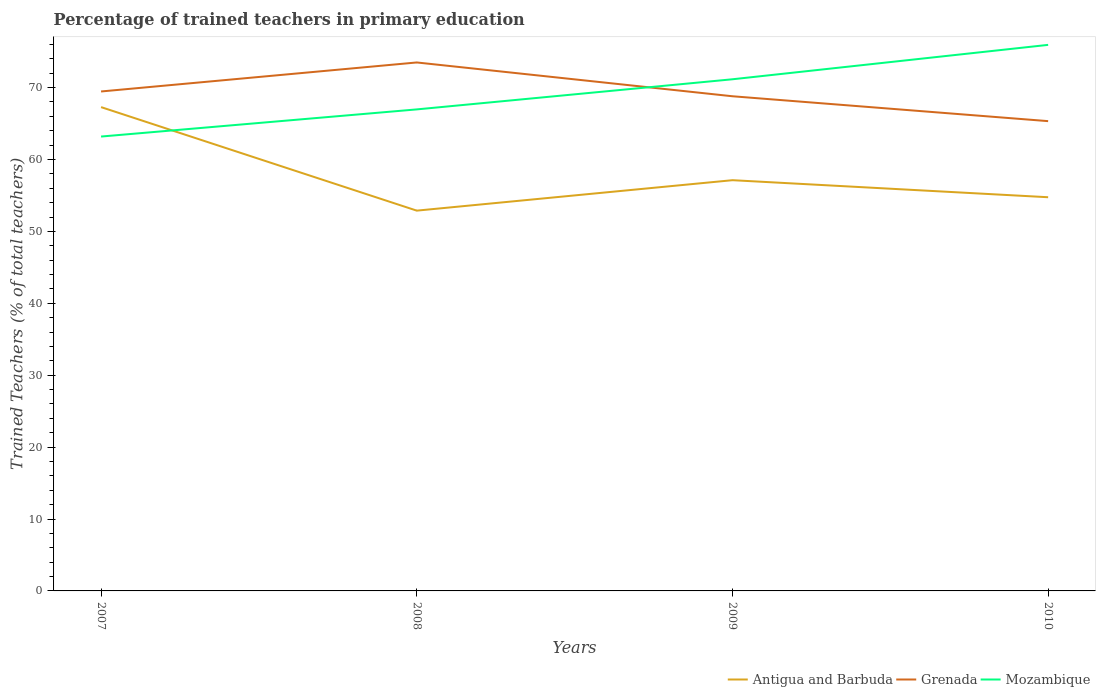How many different coloured lines are there?
Provide a succinct answer. 3. Does the line corresponding to Grenada intersect with the line corresponding to Mozambique?
Ensure brevity in your answer.  Yes. Is the number of lines equal to the number of legend labels?
Your answer should be very brief. Yes. Across all years, what is the maximum percentage of trained teachers in Mozambique?
Keep it short and to the point. 63.19. What is the total percentage of trained teachers in Mozambique in the graph?
Give a very brief answer. -7.97. What is the difference between the highest and the second highest percentage of trained teachers in Grenada?
Your answer should be compact. 8.16. What is the difference between the highest and the lowest percentage of trained teachers in Antigua and Barbuda?
Give a very brief answer. 1. How many lines are there?
Provide a succinct answer. 3. What is the difference between two consecutive major ticks on the Y-axis?
Your answer should be compact. 10. Does the graph contain grids?
Your answer should be compact. No. How many legend labels are there?
Provide a succinct answer. 3. What is the title of the graph?
Offer a terse response. Percentage of trained teachers in primary education. What is the label or title of the Y-axis?
Ensure brevity in your answer.  Trained Teachers (% of total teachers). What is the Trained Teachers (% of total teachers) of Antigua and Barbuda in 2007?
Your response must be concise. 67.29. What is the Trained Teachers (% of total teachers) of Grenada in 2007?
Keep it short and to the point. 69.46. What is the Trained Teachers (% of total teachers) in Mozambique in 2007?
Provide a succinct answer. 63.19. What is the Trained Teachers (% of total teachers) of Antigua and Barbuda in 2008?
Offer a very short reply. 52.89. What is the Trained Teachers (% of total teachers) of Grenada in 2008?
Offer a terse response. 73.5. What is the Trained Teachers (% of total teachers) of Mozambique in 2008?
Make the answer very short. 66.97. What is the Trained Teachers (% of total teachers) of Antigua and Barbuda in 2009?
Make the answer very short. 57.12. What is the Trained Teachers (% of total teachers) in Grenada in 2009?
Offer a terse response. 68.8. What is the Trained Teachers (% of total teachers) of Mozambique in 2009?
Your answer should be very brief. 71.16. What is the Trained Teachers (% of total teachers) in Antigua and Barbuda in 2010?
Offer a terse response. 54.75. What is the Trained Teachers (% of total teachers) in Grenada in 2010?
Ensure brevity in your answer.  65.33. What is the Trained Teachers (% of total teachers) of Mozambique in 2010?
Provide a short and direct response. 75.94. Across all years, what is the maximum Trained Teachers (% of total teachers) in Antigua and Barbuda?
Keep it short and to the point. 67.29. Across all years, what is the maximum Trained Teachers (% of total teachers) in Grenada?
Your answer should be very brief. 73.5. Across all years, what is the maximum Trained Teachers (% of total teachers) in Mozambique?
Provide a short and direct response. 75.94. Across all years, what is the minimum Trained Teachers (% of total teachers) of Antigua and Barbuda?
Offer a terse response. 52.89. Across all years, what is the minimum Trained Teachers (% of total teachers) of Grenada?
Offer a terse response. 65.33. Across all years, what is the minimum Trained Teachers (% of total teachers) of Mozambique?
Give a very brief answer. 63.19. What is the total Trained Teachers (% of total teachers) of Antigua and Barbuda in the graph?
Your answer should be very brief. 232.05. What is the total Trained Teachers (% of total teachers) of Grenada in the graph?
Give a very brief answer. 277.09. What is the total Trained Teachers (% of total teachers) of Mozambique in the graph?
Your answer should be very brief. 277.26. What is the difference between the Trained Teachers (% of total teachers) in Antigua and Barbuda in 2007 and that in 2008?
Give a very brief answer. 14.4. What is the difference between the Trained Teachers (% of total teachers) in Grenada in 2007 and that in 2008?
Ensure brevity in your answer.  -4.04. What is the difference between the Trained Teachers (% of total teachers) in Mozambique in 2007 and that in 2008?
Offer a very short reply. -3.78. What is the difference between the Trained Teachers (% of total teachers) in Antigua and Barbuda in 2007 and that in 2009?
Make the answer very short. 10.16. What is the difference between the Trained Teachers (% of total teachers) of Grenada in 2007 and that in 2009?
Offer a terse response. 0.67. What is the difference between the Trained Teachers (% of total teachers) of Mozambique in 2007 and that in 2009?
Offer a very short reply. -7.97. What is the difference between the Trained Teachers (% of total teachers) of Antigua and Barbuda in 2007 and that in 2010?
Your answer should be very brief. 12.53. What is the difference between the Trained Teachers (% of total teachers) of Grenada in 2007 and that in 2010?
Make the answer very short. 4.13. What is the difference between the Trained Teachers (% of total teachers) in Mozambique in 2007 and that in 2010?
Keep it short and to the point. -12.75. What is the difference between the Trained Teachers (% of total teachers) in Antigua and Barbuda in 2008 and that in 2009?
Your answer should be very brief. -4.23. What is the difference between the Trained Teachers (% of total teachers) of Grenada in 2008 and that in 2009?
Give a very brief answer. 4.7. What is the difference between the Trained Teachers (% of total teachers) of Mozambique in 2008 and that in 2009?
Ensure brevity in your answer.  -4.19. What is the difference between the Trained Teachers (% of total teachers) in Antigua and Barbuda in 2008 and that in 2010?
Keep it short and to the point. -1.86. What is the difference between the Trained Teachers (% of total teachers) in Grenada in 2008 and that in 2010?
Provide a succinct answer. 8.16. What is the difference between the Trained Teachers (% of total teachers) of Mozambique in 2008 and that in 2010?
Offer a very short reply. -8.98. What is the difference between the Trained Teachers (% of total teachers) of Antigua and Barbuda in 2009 and that in 2010?
Your answer should be compact. 2.37. What is the difference between the Trained Teachers (% of total teachers) in Grenada in 2009 and that in 2010?
Give a very brief answer. 3.46. What is the difference between the Trained Teachers (% of total teachers) in Mozambique in 2009 and that in 2010?
Make the answer very short. -4.79. What is the difference between the Trained Teachers (% of total teachers) in Antigua and Barbuda in 2007 and the Trained Teachers (% of total teachers) in Grenada in 2008?
Keep it short and to the point. -6.21. What is the difference between the Trained Teachers (% of total teachers) in Antigua and Barbuda in 2007 and the Trained Teachers (% of total teachers) in Mozambique in 2008?
Give a very brief answer. 0.32. What is the difference between the Trained Teachers (% of total teachers) in Grenada in 2007 and the Trained Teachers (% of total teachers) in Mozambique in 2008?
Your answer should be very brief. 2.49. What is the difference between the Trained Teachers (% of total teachers) of Antigua and Barbuda in 2007 and the Trained Teachers (% of total teachers) of Grenada in 2009?
Ensure brevity in your answer.  -1.51. What is the difference between the Trained Teachers (% of total teachers) in Antigua and Barbuda in 2007 and the Trained Teachers (% of total teachers) in Mozambique in 2009?
Your answer should be very brief. -3.87. What is the difference between the Trained Teachers (% of total teachers) in Grenada in 2007 and the Trained Teachers (% of total teachers) in Mozambique in 2009?
Provide a succinct answer. -1.7. What is the difference between the Trained Teachers (% of total teachers) of Antigua and Barbuda in 2007 and the Trained Teachers (% of total teachers) of Grenada in 2010?
Your response must be concise. 1.95. What is the difference between the Trained Teachers (% of total teachers) in Antigua and Barbuda in 2007 and the Trained Teachers (% of total teachers) in Mozambique in 2010?
Offer a terse response. -8.66. What is the difference between the Trained Teachers (% of total teachers) in Grenada in 2007 and the Trained Teachers (% of total teachers) in Mozambique in 2010?
Offer a terse response. -6.48. What is the difference between the Trained Teachers (% of total teachers) of Antigua and Barbuda in 2008 and the Trained Teachers (% of total teachers) of Grenada in 2009?
Offer a very short reply. -15.91. What is the difference between the Trained Teachers (% of total teachers) of Antigua and Barbuda in 2008 and the Trained Teachers (% of total teachers) of Mozambique in 2009?
Your response must be concise. -18.27. What is the difference between the Trained Teachers (% of total teachers) in Grenada in 2008 and the Trained Teachers (% of total teachers) in Mozambique in 2009?
Keep it short and to the point. 2.34. What is the difference between the Trained Teachers (% of total teachers) of Antigua and Barbuda in 2008 and the Trained Teachers (% of total teachers) of Grenada in 2010?
Keep it short and to the point. -12.45. What is the difference between the Trained Teachers (% of total teachers) of Antigua and Barbuda in 2008 and the Trained Teachers (% of total teachers) of Mozambique in 2010?
Your answer should be compact. -23.05. What is the difference between the Trained Teachers (% of total teachers) in Grenada in 2008 and the Trained Teachers (% of total teachers) in Mozambique in 2010?
Provide a short and direct response. -2.45. What is the difference between the Trained Teachers (% of total teachers) in Antigua and Barbuda in 2009 and the Trained Teachers (% of total teachers) in Grenada in 2010?
Provide a short and direct response. -8.21. What is the difference between the Trained Teachers (% of total teachers) in Antigua and Barbuda in 2009 and the Trained Teachers (% of total teachers) in Mozambique in 2010?
Make the answer very short. -18.82. What is the difference between the Trained Teachers (% of total teachers) in Grenada in 2009 and the Trained Teachers (% of total teachers) in Mozambique in 2010?
Offer a very short reply. -7.15. What is the average Trained Teachers (% of total teachers) in Antigua and Barbuda per year?
Provide a succinct answer. 58.01. What is the average Trained Teachers (% of total teachers) of Grenada per year?
Give a very brief answer. 69.27. What is the average Trained Teachers (% of total teachers) in Mozambique per year?
Offer a very short reply. 69.31. In the year 2007, what is the difference between the Trained Teachers (% of total teachers) in Antigua and Barbuda and Trained Teachers (% of total teachers) in Grenada?
Keep it short and to the point. -2.17. In the year 2007, what is the difference between the Trained Teachers (% of total teachers) in Antigua and Barbuda and Trained Teachers (% of total teachers) in Mozambique?
Provide a short and direct response. 4.09. In the year 2007, what is the difference between the Trained Teachers (% of total teachers) of Grenada and Trained Teachers (% of total teachers) of Mozambique?
Offer a terse response. 6.27. In the year 2008, what is the difference between the Trained Teachers (% of total teachers) of Antigua and Barbuda and Trained Teachers (% of total teachers) of Grenada?
Offer a terse response. -20.61. In the year 2008, what is the difference between the Trained Teachers (% of total teachers) of Antigua and Barbuda and Trained Teachers (% of total teachers) of Mozambique?
Give a very brief answer. -14.08. In the year 2008, what is the difference between the Trained Teachers (% of total teachers) in Grenada and Trained Teachers (% of total teachers) in Mozambique?
Keep it short and to the point. 6.53. In the year 2009, what is the difference between the Trained Teachers (% of total teachers) in Antigua and Barbuda and Trained Teachers (% of total teachers) in Grenada?
Give a very brief answer. -11.67. In the year 2009, what is the difference between the Trained Teachers (% of total teachers) of Antigua and Barbuda and Trained Teachers (% of total teachers) of Mozambique?
Provide a short and direct response. -14.04. In the year 2009, what is the difference between the Trained Teachers (% of total teachers) of Grenada and Trained Teachers (% of total teachers) of Mozambique?
Provide a succinct answer. -2.36. In the year 2010, what is the difference between the Trained Teachers (% of total teachers) of Antigua and Barbuda and Trained Teachers (% of total teachers) of Grenada?
Keep it short and to the point. -10.58. In the year 2010, what is the difference between the Trained Teachers (% of total teachers) in Antigua and Barbuda and Trained Teachers (% of total teachers) in Mozambique?
Ensure brevity in your answer.  -21.19. In the year 2010, what is the difference between the Trained Teachers (% of total teachers) in Grenada and Trained Teachers (% of total teachers) in Mozambique?
Ensure brevity in your answer.  -10.61. What is the ratio of the Trained Teachers (% of total teachers) of Antigua and Barbuda in 2007 to that in 2008?
Your answer should be compact. 1.27. What is the ratio of the Trained Teachers (% of total teachers) of Grenada in 2007 to that in 2008?
Your response must be concise. 0.95. What is the ratio of the Trained Teachers (% of total teachers) of Mozambique in 2007 to that in 2008?
Provide a short and direct response. 0.94. What is the ratio of the Trained Teachers (% of total teachers) of Antigua and Barbuda in 2007 to that in 2009?
Your response must be concise. 1.18. What is the ratio of the Trained Teachers (% of total teachers) of Grenada in 2007 to that in 2009?
Provide a short and direct response. 1.01. What is the ratio of the Trained Teachers (% of total teachers) of Mozambique in 2007 to that in 2009?
Your answer should be very brief. 0.89. What is the ratio of the Trained Teachers (% of total teachers) of Antigua and Barbuda in 2007 to that in 2010?
Keep it short and to the point. 1.23. What is the ratio of the Trained Teachers (% of total teachers) of Grenada in 2007 to that in 2010?
Provide a succinct answer. 1.06. What is the ratio of the Trained Teachers (% of total teachers) in Mozambique in 2007 to that in 2010?
Keep it short and to the point. 0.83. What is the ratio of the Trained Teachers (% of total teachers) in Antigua and Barbuda in 2008 to that in 2009?
Provide a succinct answer. 0.93. What is the ratio of the Trained Teachers (% of total teachers) of Grenada in 2008 to that in 2009?
Ensure brevity in your answer.  1.07. What is the ratio of the Trained Teachers (% of total teachers) of Mozambique in 2008 to that in 2009?
Your answer should be compact. 0.94. What is the ratio of the Trained Teachers (% of total teachers) in Grenada in 2008 to that in 2010?
Offer a very short reply. 1.12. What is the ratio of the Trained Teachers (% of total teachers) of Mozambique in 2008 to that in 2010?
Your answer should be very brief. 0.88. What is the ratio of the Trained Teachers (% of total teachers) in Antigua and Barbuda in 2009 to that in 2010?
Make the answer very short. 1.04. What is the ratio of the Trained Teachers (% of total teachers) of Grenada in 2009 to that in 2010?
Keep it short and to the point. 1.05. What is the ratio of the Trained Teachers (% of total teachers) in Mozambique in 2009 to that in 2010?
Your response must be concise. 0.94. What is the difference between the highest and the second highest Trained Teachers (% of total teachers) in Antigua and Barbuda?
Ensure brevity in your answer.  10.16. What is the difference between the highest and the second highest Trained Teachers (% of total teachers) of Grenada?
Provide a short and direct response. 4.04. What is the difference between the highest and the second highest Trained Teachers (% of total teachers) in Mozambique?
Make the answer very short. 4.79. What is the difference between the highest and the lowest Trained Teachers (% of total teachers) in Antigua and Barbuda?
Give a very brief answer. 14.4. What is the difference between the highest and the lowest Trained Teachers (% of total teachers) in Grenada?
Your response must be concise. 8.16. What is the difference between the highest and the lowest Trained Teachers (% of total teachers) of Mozambique?
Make the answer very short. 12.75. 